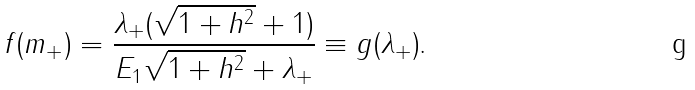<formula> <loc_0><loc_0><loc_500><loc_500>f ( m _ { + } ) = \frac { \lambda _ { + } ( \sqrt { 1 + h ^ { 2 } } + 1 ) } { E _ { 1 } \sqrt { 1 + h ^ { 2 } } + \lambda _ { + } } \equiv g ( \lambda _ { + } ) \text {.}</formula> 